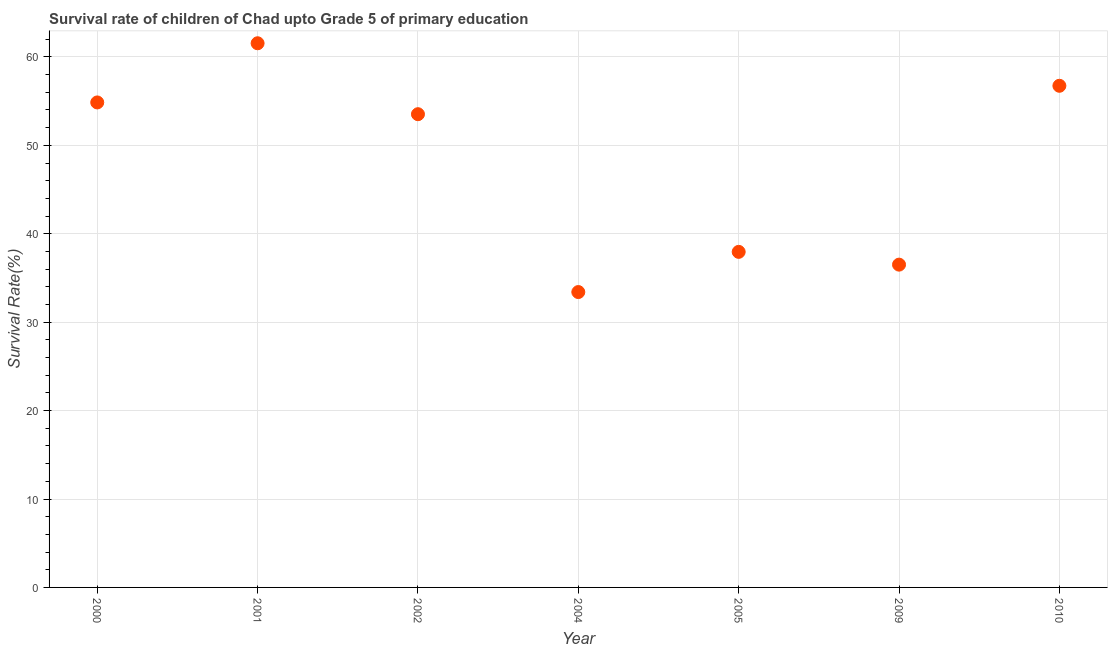What is the survival rate in 2005?
Your answer should be very brief. 37.95. Across all years, what is the maximum survival rate?
Make the answer very short. 61.54. Across all years, what is the minimum survival rate?
Ensure brevity in your answer.  33.41. In which year was the survival rate maximum?
Keep it short and to the point. 2001. In which year was the survival rate minimum?
Ensure brevity in your answer.  2004. What is the sum of the survival rate?
Your answer should be compact. 334.51. What is the difference between the survival rate in 2001 and 2002?
Your response must be concise. 8.02. What is the average survival rate per year?
Ensure brevity in your answer.  47.79. What is the median survival rate?
Make the answer very short. 53.52. What is the ratio of the survival rate in 2000 to that in 2009?
Offer a very short reply. 1.5. Is the difference between the survival rate in 2001 and 2004 greater than the difference between any two years?
Ensure brevity in your answer.  Yes. What is the difference between the highest and the second highest survival rate?
Offer a very short reply. 4.81. What is the difference between the highest and the lowest survival rate?
Your answer should be very brief. 28.14. How many dotlines are there?
Offer a very short reply. 1. What is the difference between two consecutive major ticks on the Y-axis?
Your answer should be very brief. 10. Does the graph contain grids?
Your answer should be very brief. Yes. What is the title of the graph?
Ensure brevity in your answer.  Survival rate of children of Chad upto Grade 5 of primary education. What is the label or title of the Y-axis?
Offer a terse response. Survival Rate(%). What is the Survival Rate(%) in 2000?
Provide a short and direct response. 54.85. What is the Survival Rate(%) in 2001?
Your answer should be compact. 61.54. What is the Survival Rate(%) in 2002?
Your response must be concise. 53.52. What is the Survival Rate(%) in 2004?
Make the answer very short. 33.41. What is the Survival Rate(%) in 2005?
Make the answer very short. 37.95. What is the Survival Rate(%) in 2009?
Your answer should be compact. 36.51. What is the Survival Rate(%) in 2010?
Provide a short and direct response. 56.73. What is the difference between the Survival Rate(%) in 2000 and 2001?
Your answer should be compact. -6.69. What is the difference between the Survival Rate(%) in 2000 and 2002?
Your response must be concise. 1.33. What is the difference between the Survival Rate(%) in 2000 and 2004?
Offer a terse response. 21.44. What is the difference between the Survival Rate(%) in 2000 and 2005?
Provide a short and direct response. 16.9. What is the difference between the Survival Rate(%) in 2000 and 2009?
Provide a short and direct response. 18.34. What is the difference between the Survival Rate(%) in 2000 and 2010?
Ensure brevity in your answer.  -1.88. What is the difference between the Survival Rate(%) in 2001 and 2002?
Offer a terse response. 8.02. What is the difference between the Survival Rate(%) in 2001 and 2004?
Your answer should be compact. 28.14. What is the difference between the Survival Rate(%) in 2001 and 2005?
Your response must be concise. 23.59. What is the difference between the Survival Rate(%) in 2001 and 2009?
Offer a very short reply. 25.04. What is the difference between the Survival Rate(%) in 2001 and 2010?
Give a very brief answer. 4.81. What is the difference between the Survival Rate(%) in 2002 and 2004?
Give a very brief answer. 20.12. What is the difference between the Survival Rate(%) in 2002 and 2005?
Offer a very short reply. 15.57. What is the difference between the Survival Rate(%) in 2002 and 2009?
Give a very brief answer. 17.01. What is the difference between the Survival Rate(%) in 2002 and 2010?
Make the answer very short. -3.21. What is the difference between the Survival Rate(%) in 2004 and 2005?
Offer a very short reply. -4.54. What is the difference between the Survival Rate(%) in 2004 and 2009?
Your response must be concise. -3.1. What is the difference between the Survival Rate(%) in 2004 and 2010?
Provide a short and direct response. -23.33. What is the difference between the Survival Rate(%) in 2005 and 2009?
Keep it short and to the point. 1.44. What is the difference between the Survival Rate(%) in 2005 and 2010?
Ensure brevity in your answer.  -18.78. What is the difference between the Survival Rate(%) in 2009 and 2010?
Keep it short and to the point. -20.23. What is the ratio of the Survival Rate(%) in 2000 to that in 2001?
Make the answer very short. 0.89. What is the ratio of the Survival Rate(%) in 2000 to that in 2004?
Your response must be concise. 1.64. What is the ratio of the Survival Rate(%) in 2000 to that in 2005?
Offer a very short reply. 1.45. What is the ratio of the Survival Rate(%) in 2000 to that in 2009?
Provide a succinct answer. 1.5. What is the ratio of the Survival Rate(%) in 2001 to that in 2002?
Ensure brevity in your answer.  1.15. What is the ratio of the Survival Rate(%) in 2001 to that in 2004?
Offer a very short reply. 1.84. What is the ratio of the Survival Rate(%) in 2001 to that in 2005?
Make the answer very short. 1.62. What is the ratio of the Survival Rate(%) in 2001 to that in 2009?
Provide a succinct answer. 1.69. What is the ratio of the Survival Rate(%) in 2001 to that in 2010?
Your answer should be compact. 1.08. What is the ratio of the Survival Rate(%) in 2002 to that in 2004?
Provide a succinct answer. 1.6. What is the ratio of the Survival Rate(%) in 2002 to that in 2005?
Your response must be concise. 1.41. What is the ratio of the Survival Rate(%) in 2002 to that in 2009?
Ensure brevity in your answer.  1.47. What is the ratio of the Survival Rate(%) in 2002 to that in 2010?
Offer a very short reply. 0.94. What is the ratio of the Survival Rate(%) in 2004 to that in 2009?
Make the answer very short. 0.92. What is the ratio of the Survival Rate(%) in 2004 to that in 2010?
Ensure brevity in your answer.  0.59. What is the ratio of the Survival Rate(%) in 2005 to that in 2009?
Your answer should be compact. 1.04. What is the ratio of the Survival Rate(%) in 2005 to that in 2010?
Provide a succinct answer. 0.67. What is the ratio of the Survival Rate(%) in 2009 to that in 2010?
Make the answer very short. 0.64. 